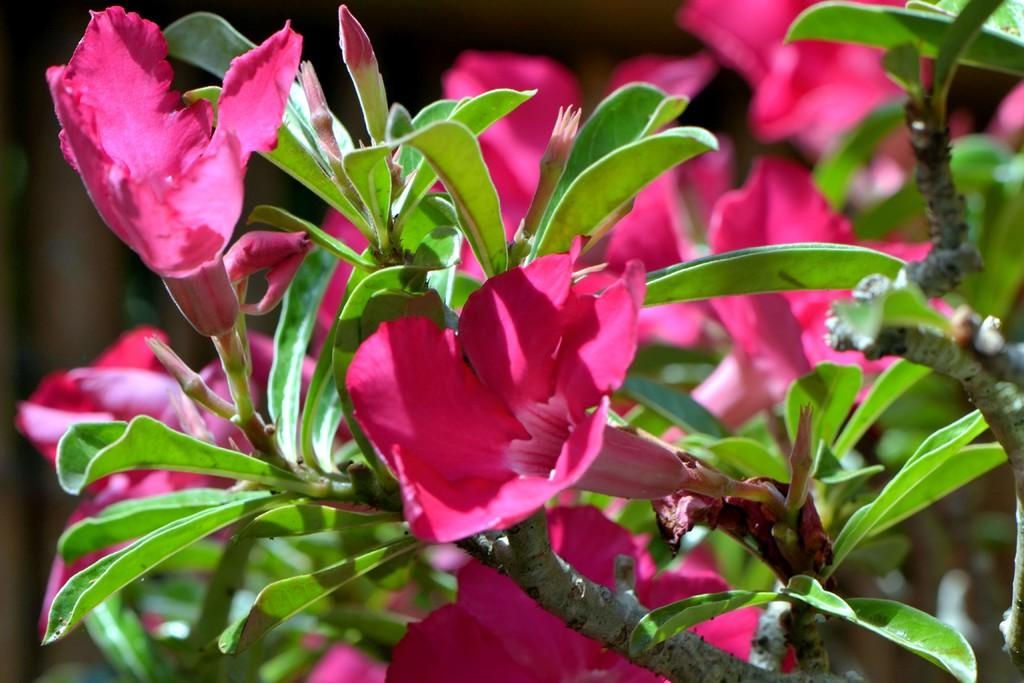What is present in the image? There is a plant in the image. What feature of the plant is mentioned? The plant has flowers. What can be said about the color of the flowers? The flowers are pink in color. How many apples are hanging from the plant in the image? There are no apples present in the image; the plant has flowers, not apples. Is there a star visible in the image? There is no star present in the image. 